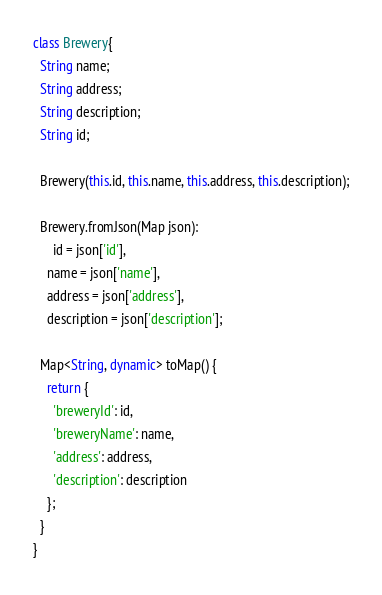Convert code to text. <code><loc_0><loc_0><loc_500><loc_500><_Dart_>class Brewery{
  String name;
  String address;
  String description;
  String id;

  Brewery(this.id, this.name, this.address, this.description);

  Brewery.fromJson(Map json):
      id = json['id'],
    name = json['name'],
    address = json['address'],
    description = json['description'];

  Map<String, dynamic> toMap() {
    return {
      'breweryId': id,
      'breweryName': name,
      'address': address,
      'description': description
    };
  }
}</code> 